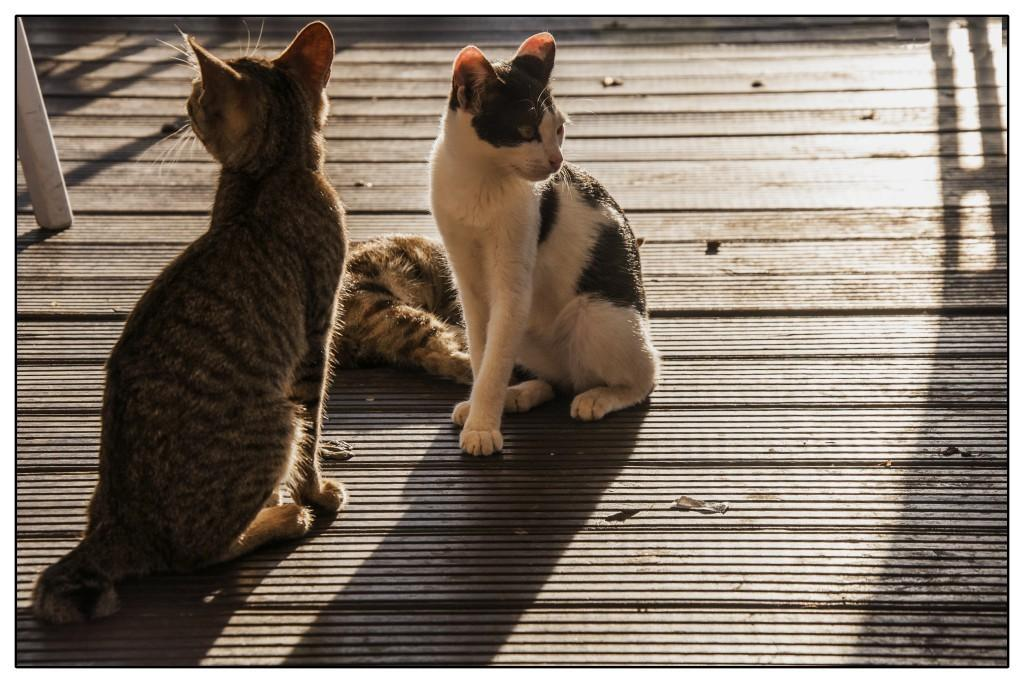How many cats are present in the image? There are three cats on a wooden surface in the image. What can be seen towards the left side of the image? There is an object towards the left of the image. What is the wooden surface covered with? There are objects on the wooden surface. What type of apples are being processed in the image? There are no apples or any indication of a process in the image; it features three cats on a wooden surface. In which direction are the cats facing in the image? The image does not provide information about the direction the cats are facing; it only shows their presence on the wooden surface. 